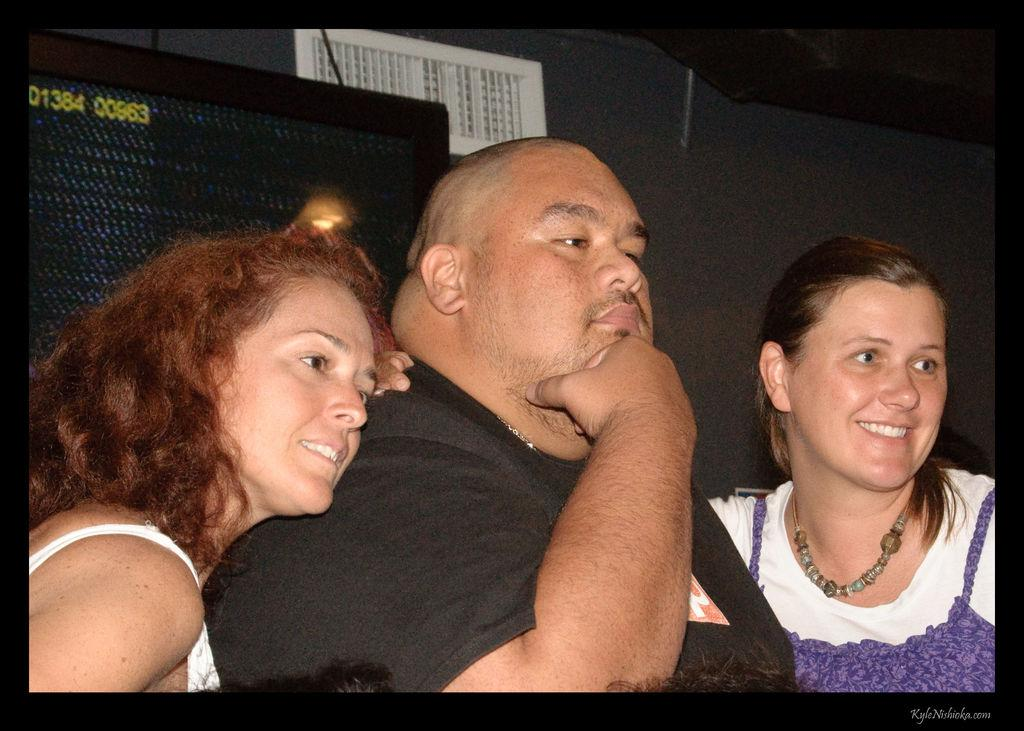How many people are in the image? There are three people in the image. What are the people in the image doing? The three people are standing. What object can be seen in the image besides the people? There is a speaker box visible in the image. What type of attempt can be seen being made by the babies in the image? There are no babies present in the image, so no such attempt can be observed. 